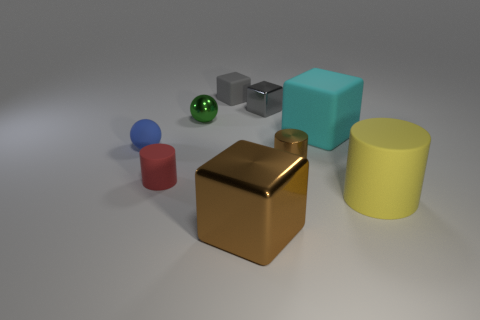Subtract all gray cubes. How many were subtracted if there are1gray cubes left? 1 Subtract all small gray matte blocks. How many blocks are left? 3 Add 1 yellow cylinders. How many objects exist? 10 Subtract all red balls. How many gray cubes are left? 2 Subtract all gray blocks. How many blocks are left? 2 Subtract 1 cylinders. How many cylinders are left? 2 Subtract all balls. How many objects are left? 7 Add 6 small metallic cylinders. How many small metallic cylinders are left? 7 Add 3 green metal spheres. How many green metal spheres exist? 4 Subtract 1 yellow cylinders. How many objects are left? 8 